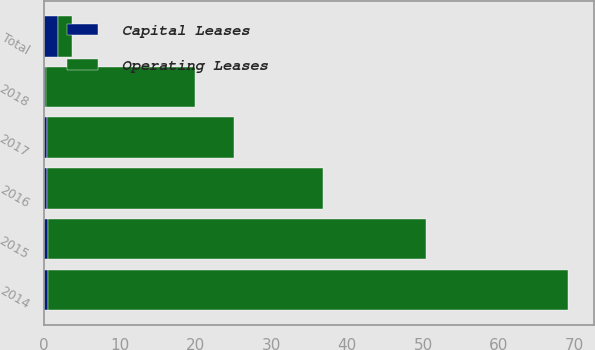<chart> <loc_0><loc_0><loc_500><loc_500><stacked_bar_chart><ecel><fcel>2014<fcel>2015<fcel>2016<fcel>2017<fcel>2018<fcel>Total<nl><fcel>Capital Leases<fcel>0.5<fcel>0.5<fcel>0.3<fcel>0.3<fcel>0.2<fcel>1.8<nl><fcel>Operating Leases<fcel>68.6<fcel>49.9<fcel>36.5<fcel>24.7<fcel>19.7<fcel>1.8<nl></chart> 